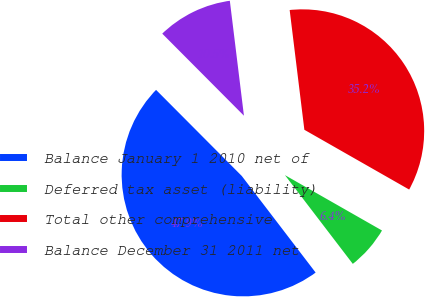Convert chart to OTSL. <chart><loc_0><loc_0><loc_500><loc_500><pie_chart><fcel>Balance January 1 2010 net of<fcel>Deferred tax asset (liability)<fcel>Total other comprehensive<fcel>Balance December 31 2011 net<nl><fcel>47.92%<fcel>6.36%<fcel>35.19%<fcel>10.52%<nl></chart> 